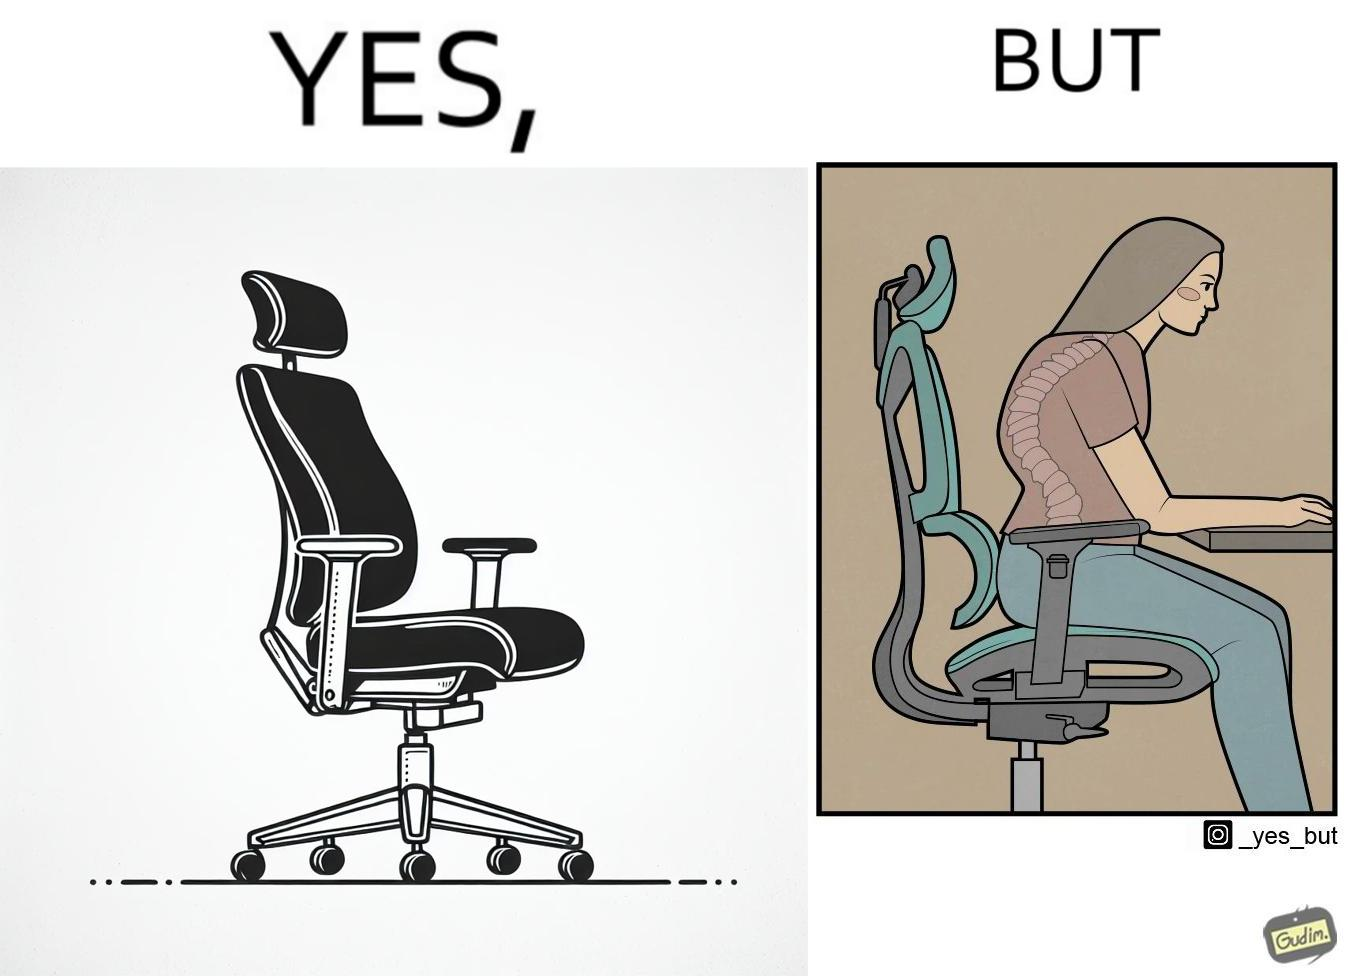Describe the content of this image. The image is ironical, as even though the ergonomic chair is meant to facilitate an upright and comfortable posture for the person sitting on it, the person sitting on it still has a bent posture, as the person is not utilizing the backrest. 